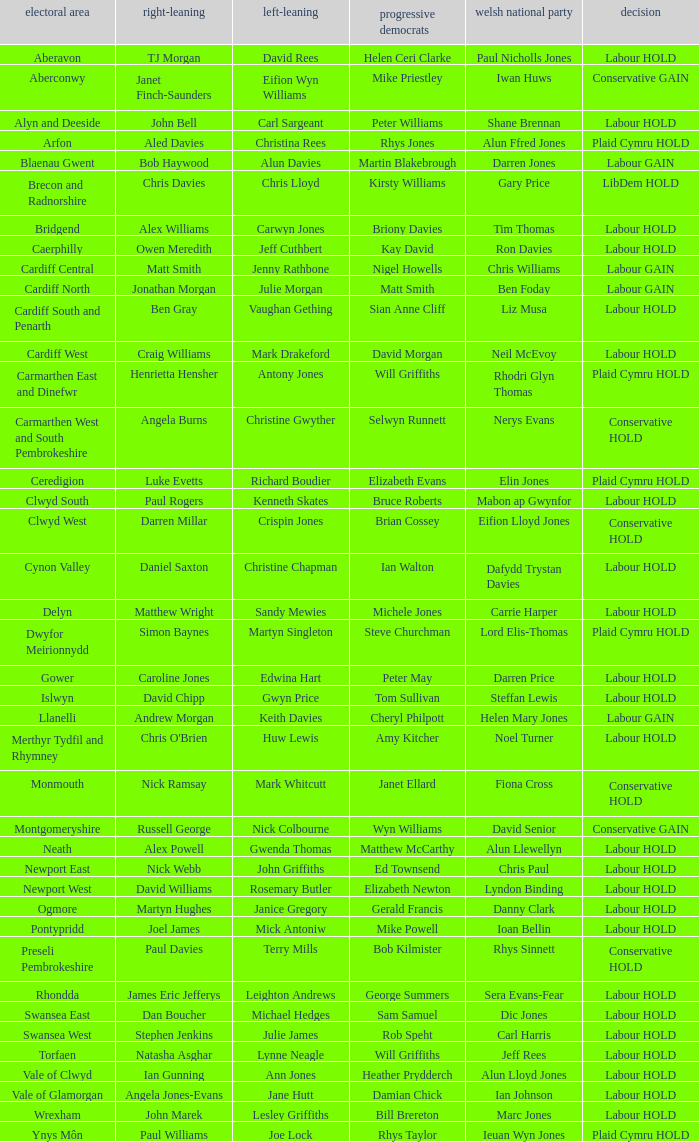What constituency does the Conservative Darren Millar belong to? Clwyd West. 